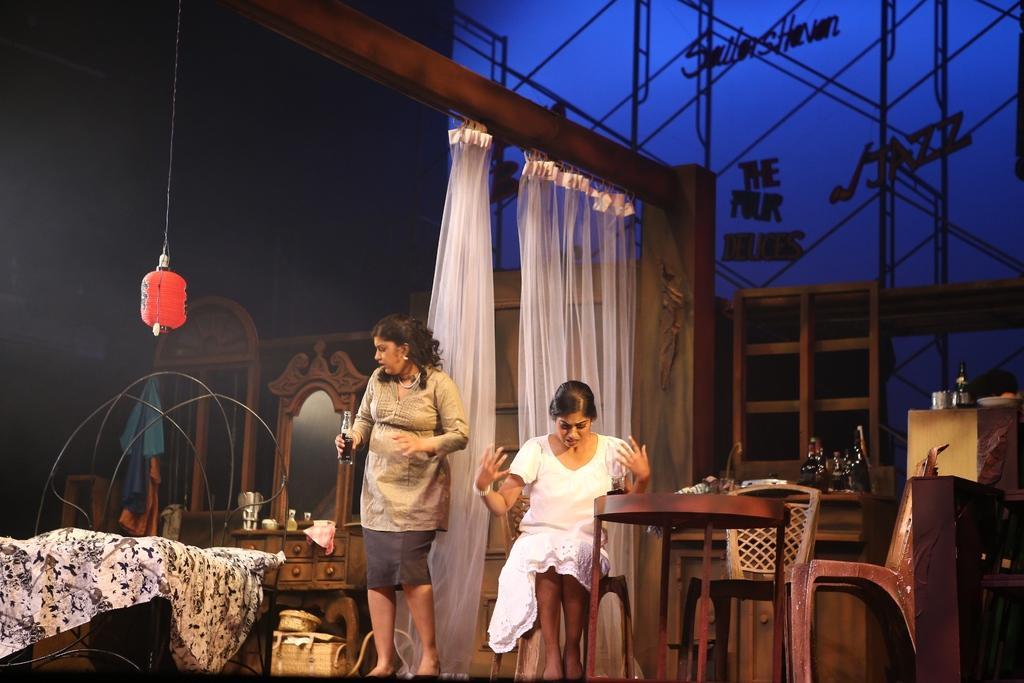Can you describe this image briefly? The women wearing a white dress sat in a chair and the other women wearing light brown dress holding beverage in her hand stood up and there is a white bed sheet on the left side and a mirror and window on the left side and there is also a curtain on the background and there are also two chairs left empty on the right side and there are also wine bottles on the table and the background on the top right is blue color with a jazz written on it. 